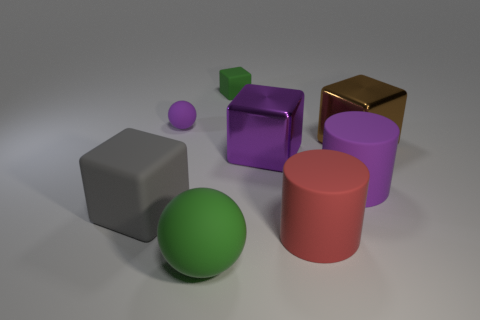Add 1 cyan rubber cylinders. How many objects exist? 9 Subtract all cylinders. How many objects are left? 6 Subtract all small rubber cylinders. Subtract all large purple objects. How many objects are left? 6 Add 1 purple rubber cylinders. How many purple rubber cylinders are left? 2 Add 5 big green things. How many big green things exist? 6 Subtract 1 purple spheres. How many objects are left? 7 